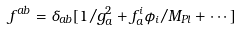Convert formula to latex. <formula><loc_0><loc_0><loc_500><loc_500>f ^ { a b } = \delta _ { a b } [ 1 / g _ { a } ^ { 2 } + f _ { a } ^ { i } \phi _ { i } / M _ { P l } + \cdots ]</formula> 